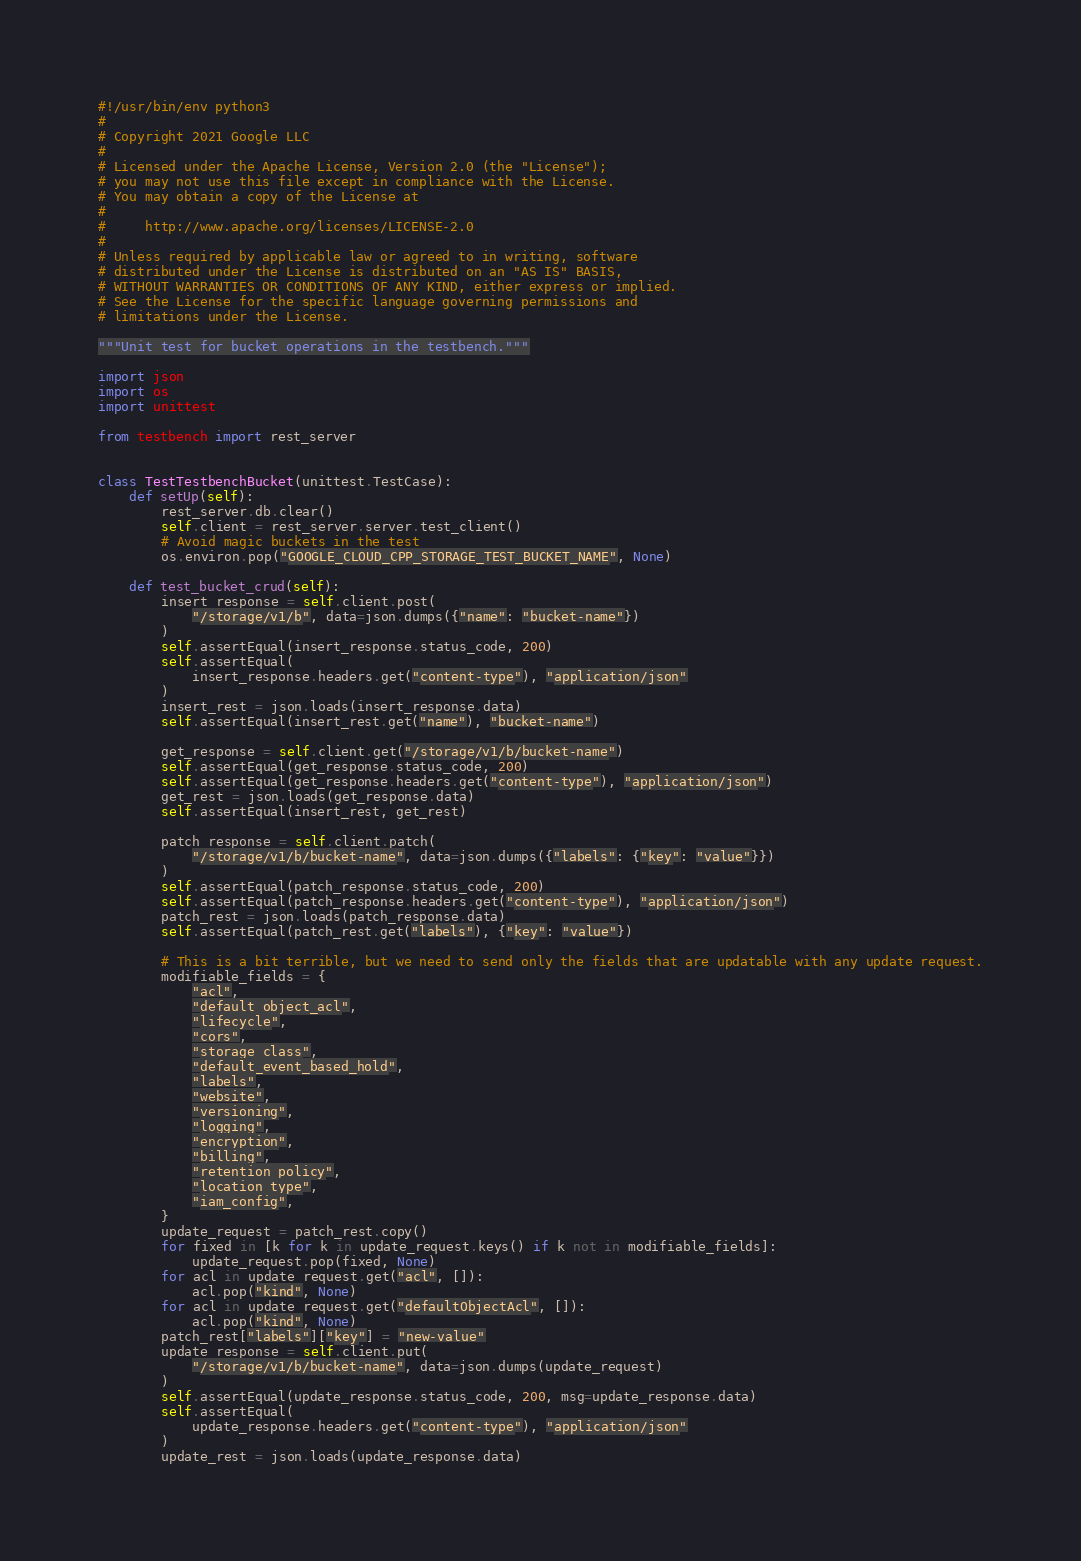Convert code to text. <code><loc_0><loc_0><loc_500><loc_500><_Python_>#!/usr/bin/env python3
#
# Copyright 2021 Google LLC
#
# Licensed under the Apache License, Version 2.0 (the "License");
# you may not use this file except in compliance with the License.
# You may obtain a copy of the License at
#
#     http://www.apache.org/licenses/LICENSE-2.0
#
# Unless required by applicable law or agreed to in writing, software
# distributed under the License is distributed on an "AS IS" BASIS,
# WITHOUT WARRANTIES OR CONDITIONS OF ANY KIND, either express or implied.
# See the License for the specific language governing permissions and
# limitations under the License.

"""Unit test for bucket operations in the testbench."""

import json
import os
import unittest

from testbench import rest_server


class TestTestbenchBucket(unittest.TestCase):
    def setUp(self):
        rest_server.db.clear()
        self.client = rest_server.server.test_client()
        # Avoid magic buckets in the test
        os.environ.pop("GOOGLE_CLOUD_CPP_STORAGE_TEST_BUCKET_NAME", None)

    def test_bucket_crud(self):
        insert_response = self.client.post(
            "/storage/v1/b", data=json.dumps({"name": "bucket-name"})
        )
        self.assertEqual(insert_response.status_code, 200)
        self.assertEqual(
            insert_response.headers.get("content-type"), "application/json"
        )
        insert_rest = json.loads(insert_response.data)
        self.assertEqual(insert_rest.get("name"), "bucket-name")

        get_response = self.client.get("/storage/v1/b/bucket-name")
        self.assertEqual(get_response.status_code, 200)
        self.assertEqual(get_response.headers.get("content-type"), "application/json")
        get_rest = json.loads(get_response.data)
        self.assertEqual(insert_rest, get_rest)

        patch_response = self.client.patch(
            "/storage/v1/b/bucket-name", data=json.dumps({"labels": {"key": "value"}})
        )
        self.assertEqual(patch_response.status_code, 200)
        self.assertEqual(patch_response.headers.get("content-type"), "application/json")
        patch_rest = json.loads(patch_response.data)
        self.assertEqual(patch_rest.get("labels"), {"key": "value"})

        # This is a bit terrible, but we need to send only the fields that are updatable with any update request.
        modifiable_fields = {
            "acl",
            "default_object_acl",
            "lifecycle",
            "cors",
            "storage_class",
            "default_event_based_hold",
            "labels",
            "website",
            "versioning",
            "logging",
            "encryption",
            "billing",
            "retention_policy",
            "location_type",
            "iam_config",
        }
        update_request = patch_rest.copy()
        for fixed in [k for k in update_request.keys() if k not in modifiable_fields]:
            update_request.pop(fixed, None)
        for acl in update_request.get("acl", []):
            acl.pop("kind", None)
        for acl in update_request.get("defaultObjectAcl", []):
            acl.pop("kind", None)
        patch_rest["labels"]["key"] = "new-value"
        update_response = self.client.put(
            "/storage/v1/b/bucket-name", data=json.dumps(update_request)
        )
        self.assertEqual(update_response.status_code, 200, msg=update_response.data)
        self.assertEqual(
            update_response.headers.get("content-type"), "application/json"
        )
        update_rest = json.loads(update_response.data)</code> 